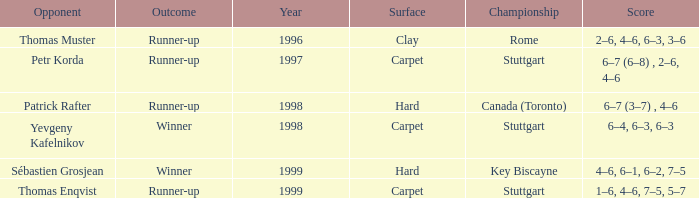How many years was the opponent petr korda? 1.0. 